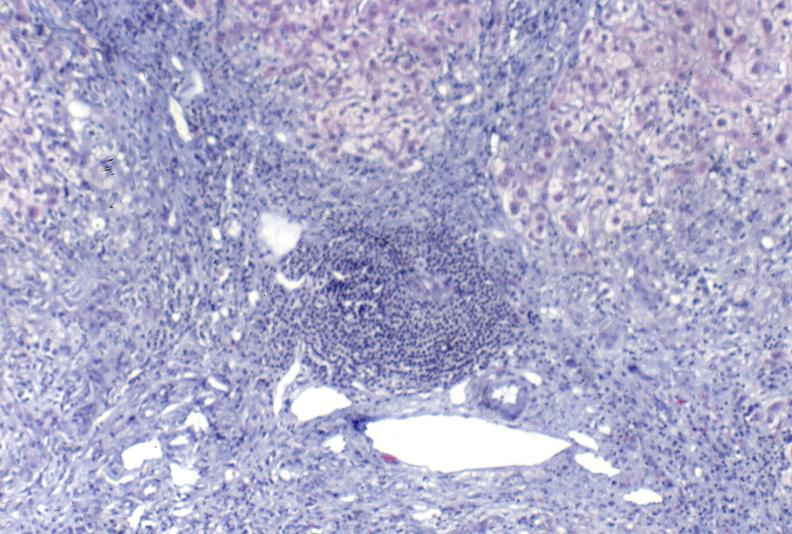s metastatic pancreas carcinoma present?
Answer the question using a single word or phrase. No 